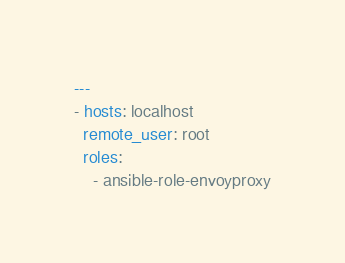Convert code to text. <code><loc_0><loc_0><loc_500><loc_500><_YAML_>---
- hosts: localhost
  remote_user: root
  roles:
    - ansible-role-envoyproxy
</code> 